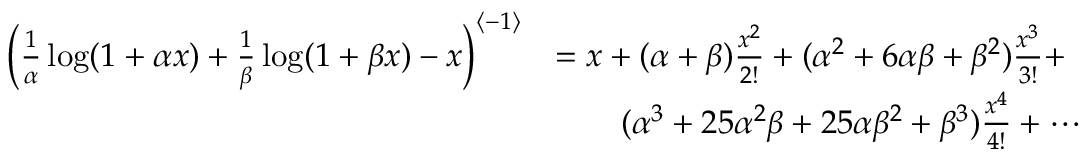Convert formula to latex. <formula><loc_0><loc_0><loc_500><loc_500>\begin{array} { r l } { \left ( \frac { 1 } { \alpha } \log ( 1 + \alpha x ) + \frac { 1 } { \beta } \log ( 1 + \beta x ) - x \right ) ^ { \left < - 1 \right > } } & { = x + ( \alpha + \beta ) \frac { x ^ { 2 } } { 2 ! } + ( \alpha ^ { 2 } + 6 \alpha \beta + \beta ^ { 2 } ) \frac { x ^ { 3 } } { 3 ! } + } \\ & { \quad ( \alpha ^ { 3 } + 2 5 \alpha ^ { 2 } \beta + 2 5 \alpha \beta ^ { 2 } + \beta ^ { 3 } ) \frac { x ^ { 4 } } { 4 ! } + \cdots } \end{array}</formula> 